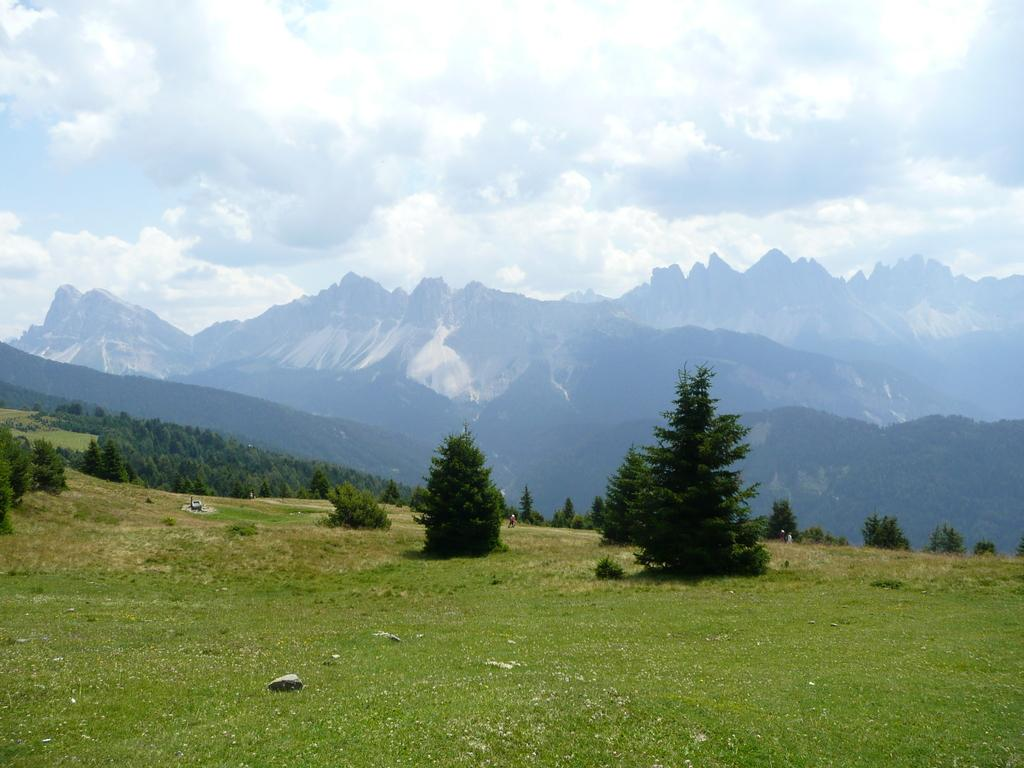What type of vegetation is present in the image? There is grass in the image. What other natural elements can be seen in the image? There are trees and mountains visible in the image. What is visible in the background of the image? The sky is visible in the background of the image. Can you tell me how many giraffes are standing among the trees in the image? There are no giraffes present in the image; it features grass, trees, mountains, and the sky. What type of ornament is hanging from the branches of the trees in the image? There is no ornament hanging from the branches of the trees in the image; it only features grass, trees, mountains, and the sky. 